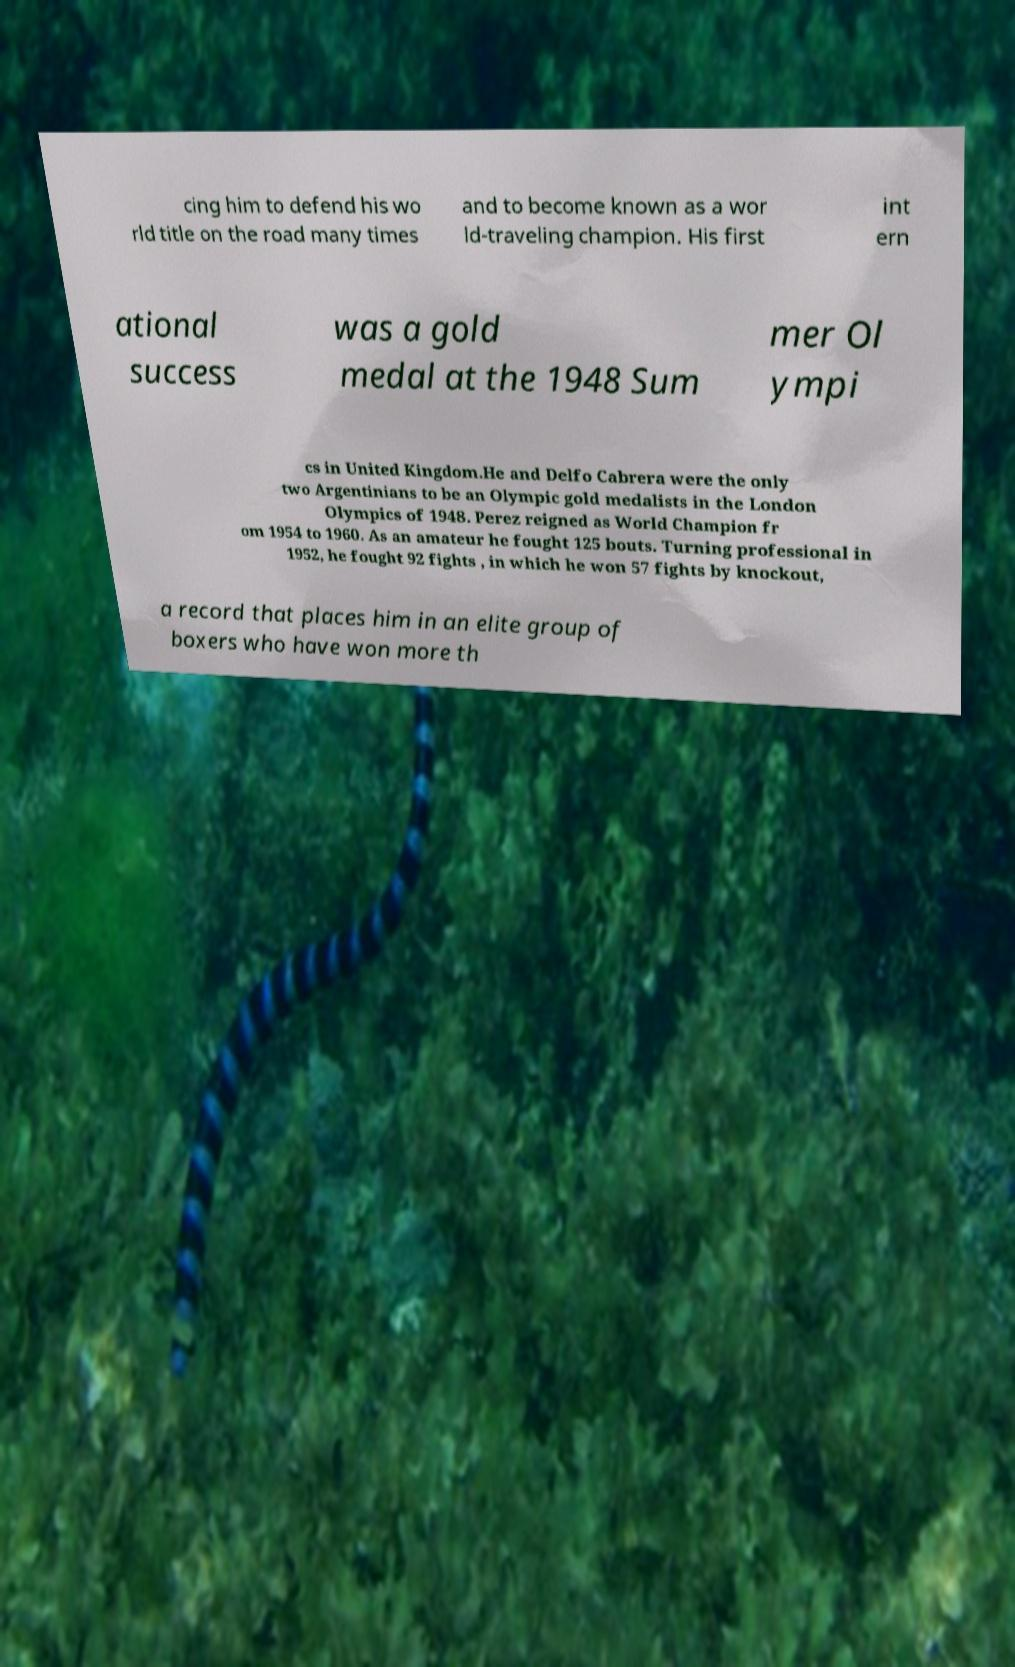There's text embedded in this image that I need extracted. Can you transcribe it verbatim? cing him to defend his wo rld title on the road many times and to become known as a wor ld-traveling champion. His first int ern ational success was a gold medal at the 1948 Sum mer Ol ympi cs in United Kingdom.He and Delfo Cabrera were the only two Argentinians to be an Olympic gold medalists in the London Olympics of 1948. Perez reigned as World Champion fr om 1954 to 1960. As an amateur he fought 125 bouts. Turning professional in 1952, he fought 92 fights , in which he won 57 fights by knockout, a record that places him in an elite group of boxers who have won more th 